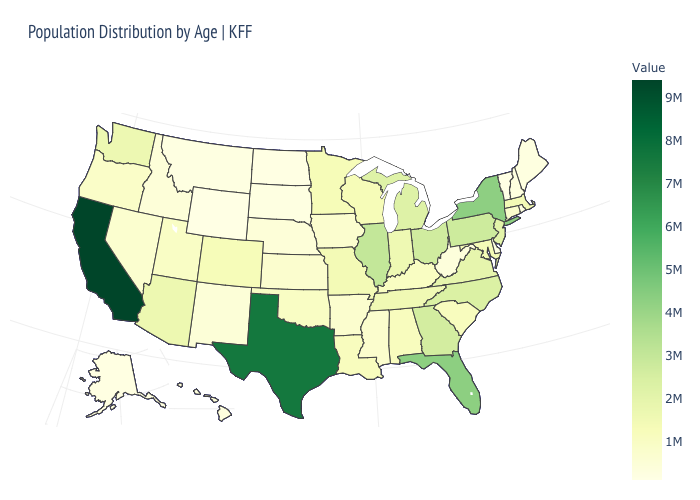Is the legend a continuous bar?
Keep it brief. Yes. Among the states that border Wisconsin , which have the highest value?
Answer briefly. Illinois. Does Arkansas have the lowest value in the USA?
Give a very brief answer. No. Which states have the lowest value in the USA?
Answer briefly. Vermont. Does California have the highest value in the USA?
Be succinct. Yes. Does Vermont have the lowest value in the USA?
Quick response, please. Yes. 